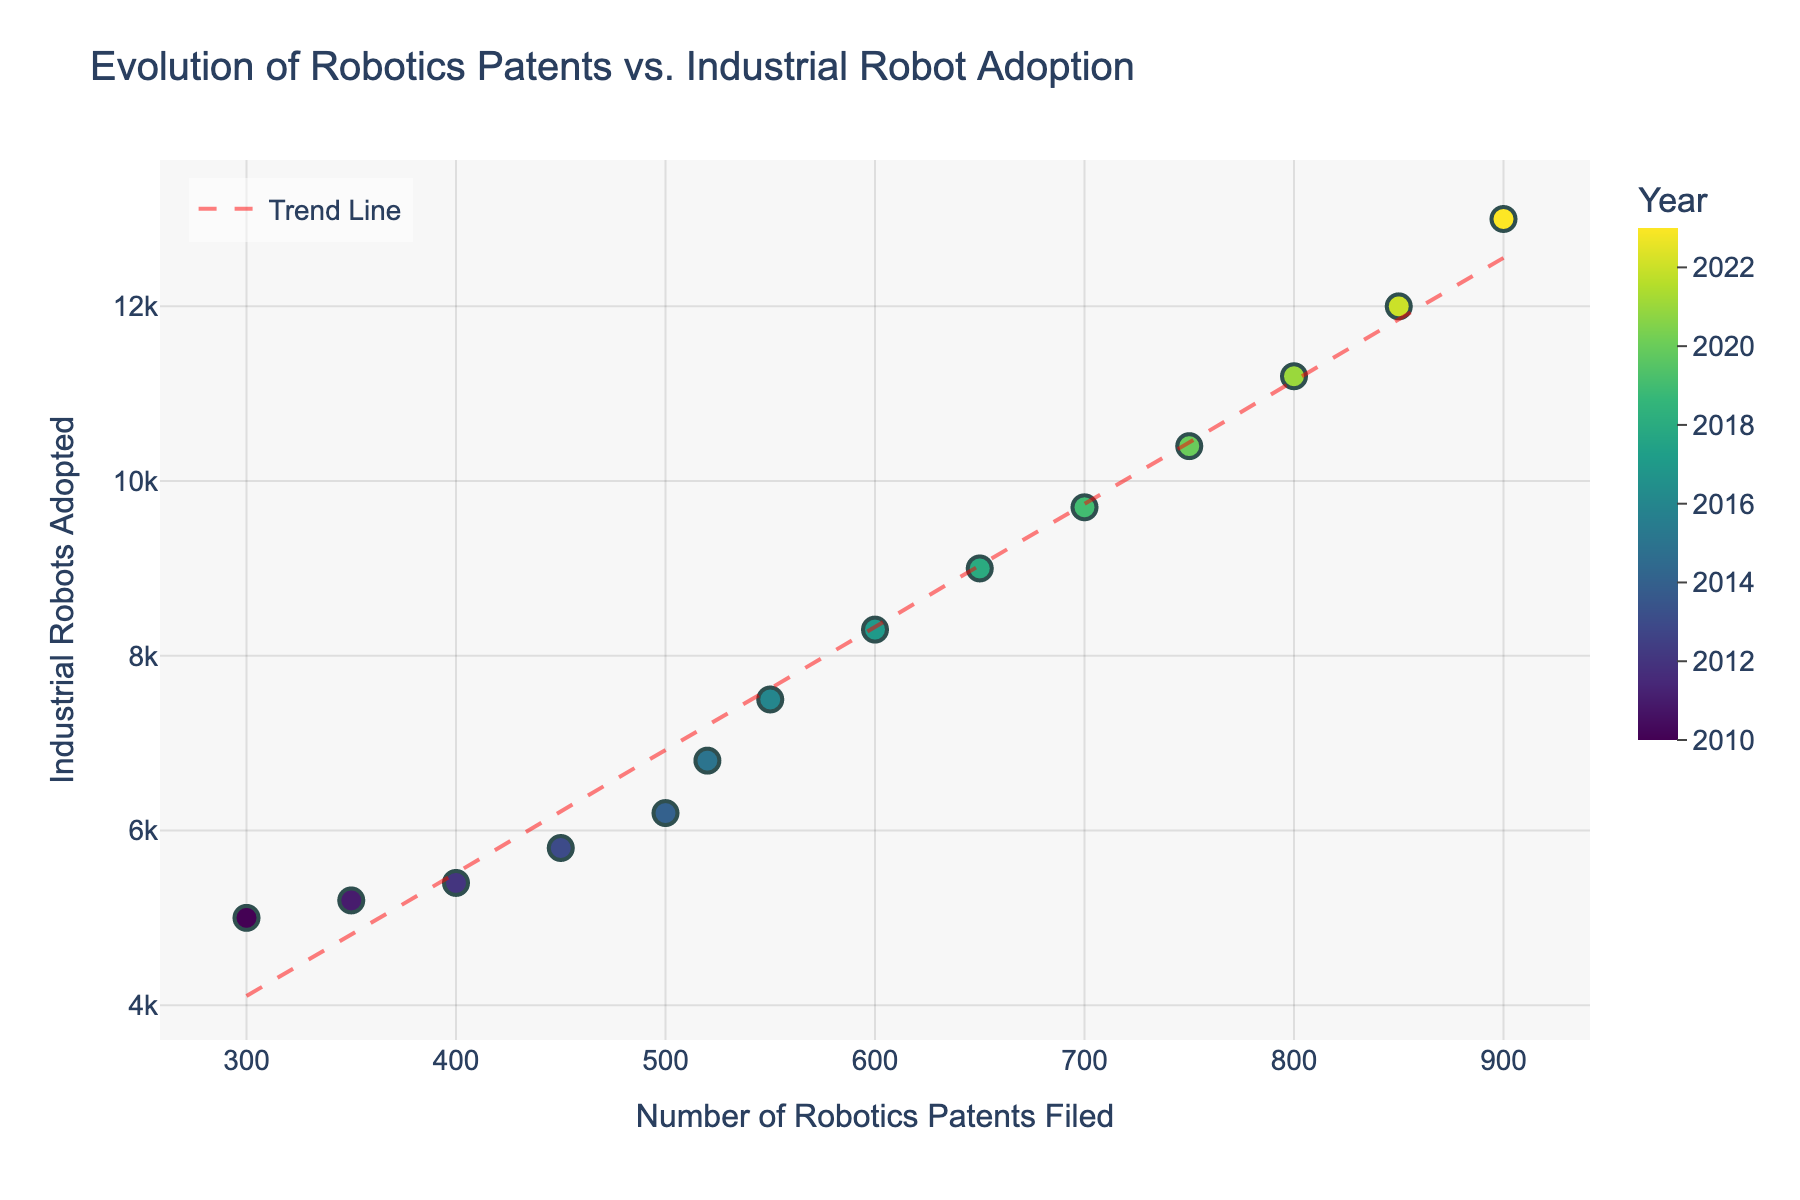What's the title of the figure? The title of the figure is usually displayed at the top of the plot. The title in this plot is 'Evolution of Robotics Patents vs. Industrial Robot Adoption'.
Answer: Evolution of Robotics Patents vs. Industrial Robot Adoption How many data points are displayed in the scatter plot? You can count the number of individual markers representing data points. Here, there are markers for each year from 2010 to 2023, thus there are 14 data points.
Answer: 14 Which year had the highest number of Industrial Robots Adopted? The highest number of Industrial Robots Adopted can be identified by looking for the highest y-value on the scatter plot. In this case, the highest y-value corresponds to the year 2023 with 13,000 industrial robots adopted.
Answer: 2023 What's the general trend indicated by the red dashed line? The red dashed line is a trend line based on the data points. By observing its slope, we can infer whether the relationship between the number of Robotics Patents Filed and Industrial Robots Adopted is positive or negative. Here, the positive slope indicates that as the number of Robotics Patents Filed increases, the Industrial Robots Adopted also tends to increase.
Answer: Positive Trend Which year had a significant increase in Industrial Robots Adopted compared to the previous year? When comparing year-by-year, one can identify 2015 as a significant increase. In 2014, 6200 robots were adopted, while in 2015, the number jumped to 6800, an increase of 600 robots, which is one of the larger jumps in the dataset.
Answer: 2015 What is the correlation between the number of Robotics Patents Filed and Industrial Robots Adopted? By observing the scatter plot and the trend line, we can determine the correlation. The positive trend line indicates a positive correlation, meaning that as one variable increases, the other also tends to increase.
Answer: Positive Correlation Between which years do you observe the smallest increase in the number of Robotics Patents Filed? To find the smallest increase, check the difference between successive years for the number of Patents Filed. The smallest increase occurs between 2014 (500 patents) and 2015 (520 patents), an increase of 20 patents.
Answer: 2014 to 2015 How many Industrial Robots were adopted when 550 robotics patents were filed? Locate the data point where 550 patents were filed and read the corresponding y-value for Industrial Robots Adopted. This corresponds to the year 2016 with 7500 robots adopted.
Answer: 7500 What does the color gradient represent in this scatter plot? The color gradient represents the years, using a continuous Viridis color scale ranging from earlier years to later years.
Answer: Years From 2016 to 2018, by how much did the number of Industrial Robots Adopted change? Check the y-values for 2016 (7500 robots) and 2018 (9000 robots) and compute the difference. The increase in the number of Industrial Robots Adopted is 9000 - 7500 = 1500.
Answer: 1500 